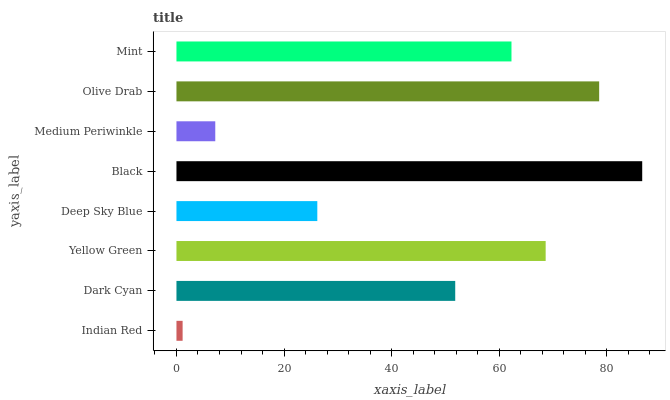Is Indian Red the minimum?
Answer yes or no. Yes. Is Black the maximum?
Answer yes or no. Yes. Is Dark Cyan the minimum?
Answer yes or no. No. Is Dark Cyan the maximum?
Answer yes or no. No. Is Dark Cyan greater than Indian Red?
Answer yes or no. Yes. Is Indian Red less than Dark Cyan?
Answer yes or no. Yes. Is Indian Red greater than Dark Cyan?
Answer yes or no. No. Is Dark Cyan less than Indian Red?
Answer yes or no. No. Is Mint the high median?
Answer yes or no. Yes. Is Dark Cyan the low median?
Answer yes or no. Yes. Is Dark Cyan the high median?
Answer yes or no. No. Is Black the low median?
Answer yes or no. No. 